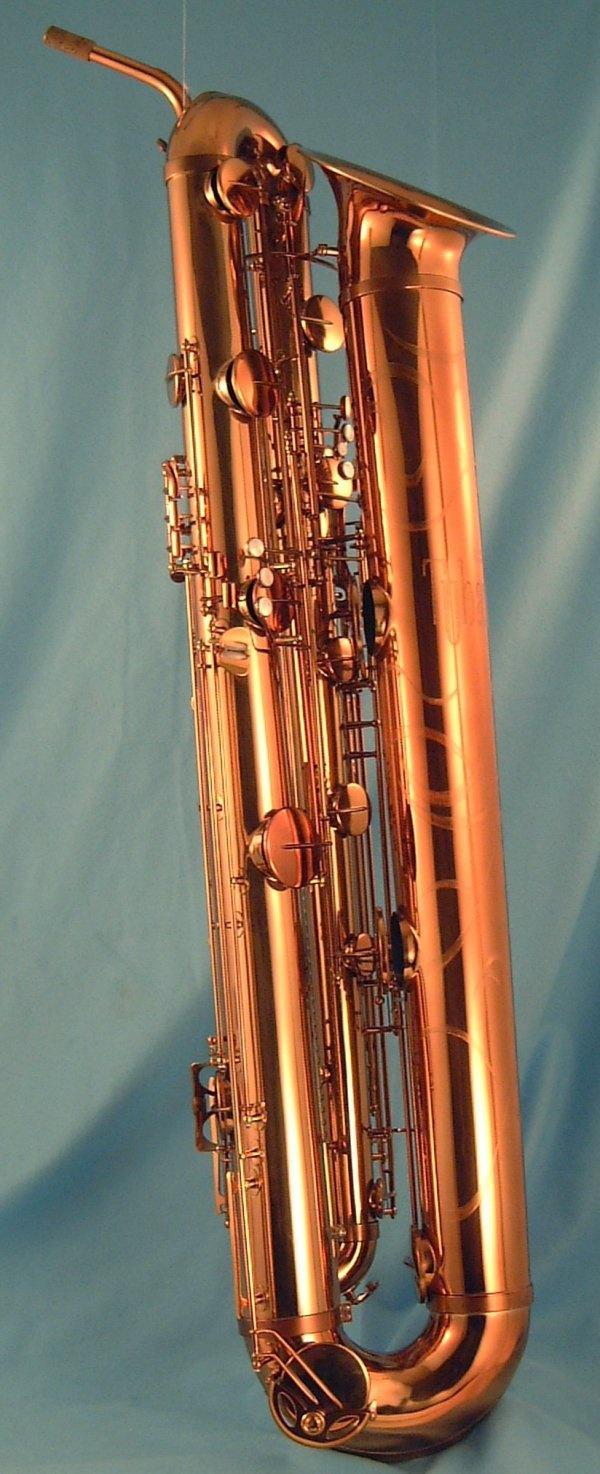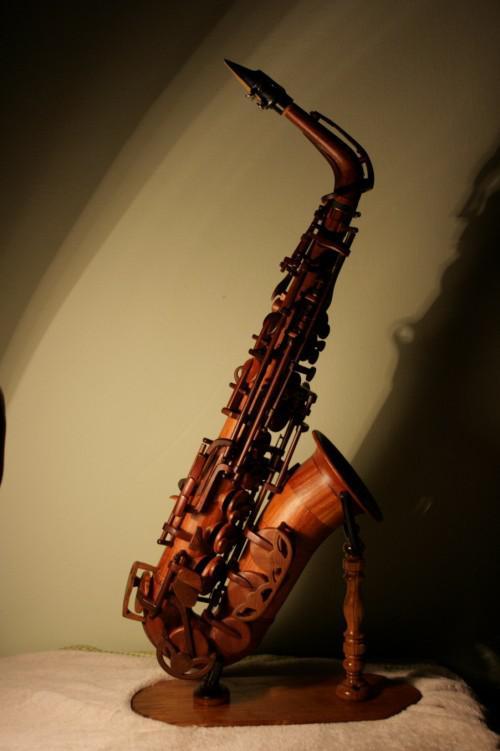The first image is the image on the left, the second image is the image on the right. For the images shown, is this caption "The entire instrument is visible in every image." true? Answer yes or no. Yes. 